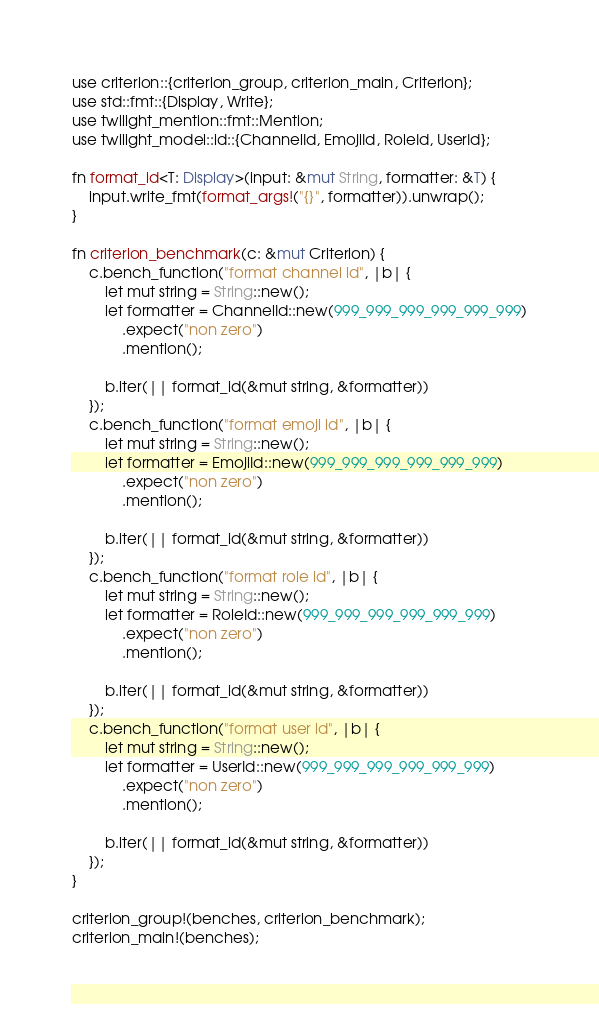<code> <loc_0><loc_0><loc_500><loc_500><_Rust_>use criterion::{criterion_group, criterion_main, Criterion};
use std::fmt::{Display, Write};
use twilight_mention::fmt::Mention;
use twilight_model::id::{ChannelId, EmojiId, RoleId, UserId};

fn format_id<T: Display>(input: &mut String, formatter: &T) {
    input.write_fmt(format_args!("{}", formatter)).unwrap();
}

fn criterion_benchmark(c: &mut Criterion) {
    c.bench_function("format channel id", |b| {
        let mut string = String::new();
        let formatter = ChannelId::new(999_999_999_999_999_999)
            .expect("non zero")
            .mention();

        b.iter(|| format_id(&mut string, &formatter))
    });
    c.bench_function("format emoji id", |b| {
        let mut string = String::new();
        let formatter = EmojiId::new(999_999_999_999_999_999)
            .expect("non zero")
            .mention();

        b.iter(|| format_id(&mut string, &formatter))
    });
    c.bench_function("format role id", |b| {
        let mut string = String::new();
        let formatter = RoleId::new(999_999_999_999_999_999)
            .expect("non zero")
            .mention();

        b.iter(|| format_id(&mut string, &formatter))
    });
    c.bench_function("format user id", |b| {
        let mut string = String::new();
        let formatter = UserId::new(999_999_999_999_999_999)
            .expect("non zero")
            .mention();

        b.iter(|| format_id(&mut string, &formatter))
    });
}

criterion_group!(benches, criterion_benchmark);
criterion_main!(benches);
</code> 